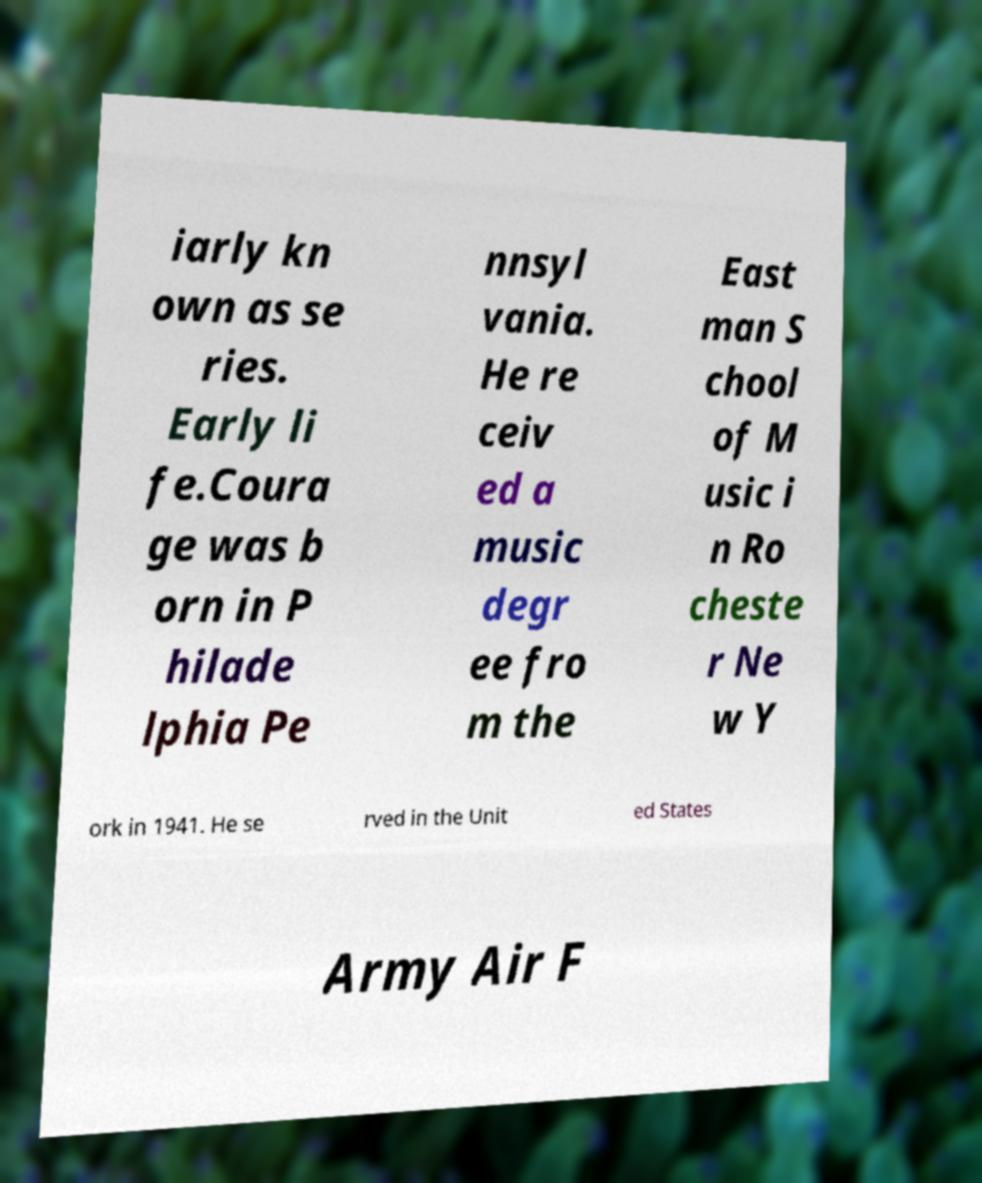Could you assist in decoding the text presented in this image and type it out clearly? iarly kn own as se ries. Early li fe.Coura ge was b orn in P hilade lphia Pe nnsyl vania. He re ceiv ed a music degr ee fro m the East man S chool of M usic i n Ro cheste r Ne w Y ork in 1941. He se rved in the Unit ed States Army Air F 